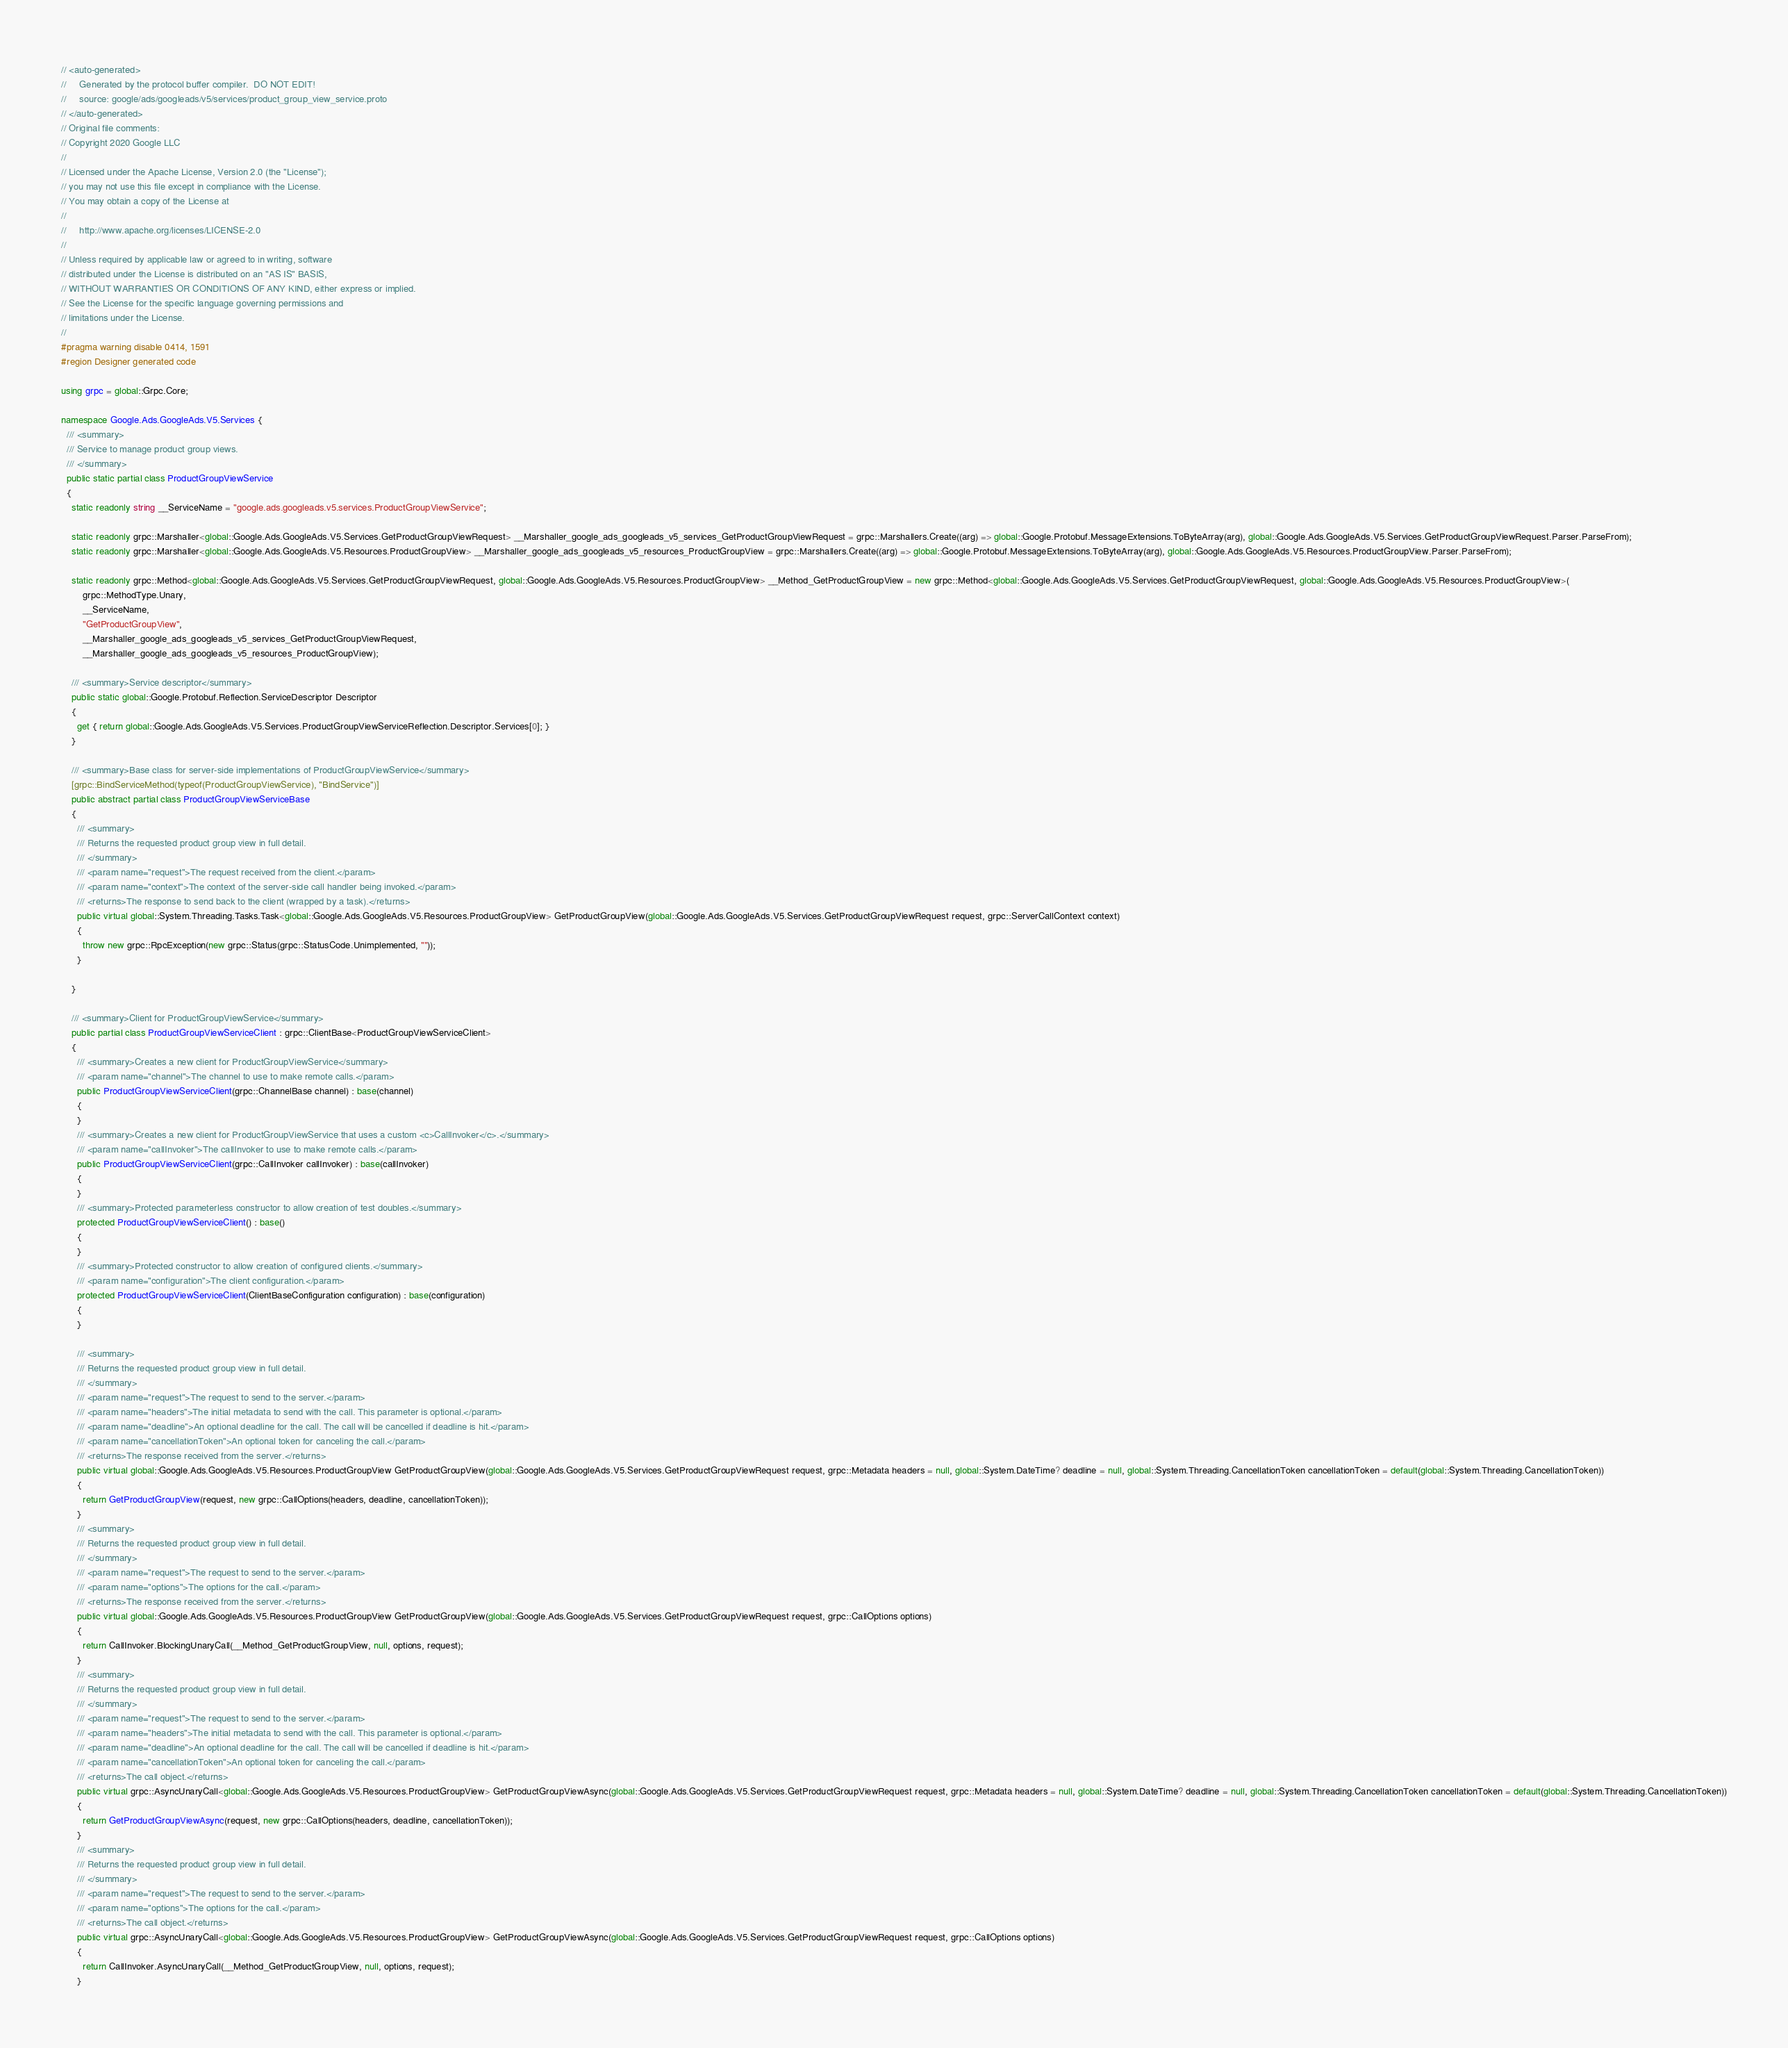<code> <loc_0><loc_0><loc_500><loc_500><_C#_>// <auto-generated>
//     Generated by the protocol buffer compiler.  DO NOT EDIT!
//     source: google/ads/googleads/v5/services/product_group_view_service.proto
// </auto-generated>
// Original file comments:
// Copyright 2020 Google LLC
//
// Licensed under the Apache License, Version 2.0 (the "License");
// you may not use this file except in compliance with the License.
// You may obtain a copy of the License at
//
//     http://www.apache.org/licenses/LICENSE-2.0
//
// Unless required by applicable law or agreed to in writing, software
// distributed under the License is distributed on an "AS IS" BASIS,
// WITHOUT WARRANTIES OR CONDITIONS OF ANY KIND, either express or implied.
// See the License for the specific language governing permissions and
// limitations under the License.
//
#pragma warning disable 0414, 1591
#region Designer generated code

using grpc = global::Grpc.Core;

namespace Google.Ads.GoogleAds.V5.Services {
  /// <summary>
  /// Service to manage product group views.
  /// </summary>
  public static partial class ProductGroupViewService
  {
    static readonly string __ServiceName = "google.ads.googleads.v5.services.ProductGroupViewService";

    static readonly grpc::Marshaller<global::Google.Ads.GoogleAds.V5.Services.GetProductGroupViewRequest> __Marshaller_google_ads_googleads_v5_services_GetProductGroupViewRequest = grpc::Marshallers.Create((arg) => global::Google.Protobuf.MessageExtensions.ToByteArray(arg), global::Google.Ads.GoogleAds.V5.Services.GetProductGroupViewRequest.Parser.ParseFrom);
    static readonly grpc::Marshaller<global::Google.Ads.GoogleAds.V5.Resources.ProductGroupView> __Marshaller_google_ads_googleads_v5_resources_ProductGroupView = grpc::Marshallers.Create((arg) => global::Google.Protobuf.MessageExtensions.ToByteArray(arg), global::Google.Ads.GoogleAds.V5.Resources.ProductGroupView.Parser.ParseFrom);

    static readonly grpc::Method<global::Google.Ads.GoogleAds.V5.Services.GetProductGroupViewRequest, global::Google.Ads.GoogleAds.V5.Resources.ProductGroupView> __Method_GetProductGroupView = new grpc::Method<global::Google.Ads.GoogleAds.V5.Services.GetProductGroupViewRequest, global::Google.Ads.GoogleAds.V5.Resources.ProductGroupView>(
        grpc::MethodType.Unary,
        __ServiceName,
        "GetProductGroupView",
        __Marshaller_google_ads_googleads_v5_services_GetProductGroupViewRequest,
        __Marshaller_google_ads_googleads_v5_resources_ProductGroupView);

    /// <summary>Service descriptor</summary>
    public static global::Google.Protobuf.Reflection.ServiceDescriptor Descriptor
    {
      get { return global::Google.Ads.GoogleAds.V5.Services.ProductGroupViewServiceReflection.Descriptor.Services[0]; }
    }

    /// <summary>Base class for server-side implementations of ProductGroupViewService</summary>
    [grpc::BindServiceMethod(typeof(ProductGroupViewService), "BindService")]
    public abstract partial class ProductGroupViewServiceBase
    {
      /// <summary>
      /// Returns the requested product group view in full detail.
      /// </summary>
      /// <param name="request">The request received from the client.</param>
      /// <param name="context">The context of the server-side call handler being invoked.</param>
      /// <returns>The response to send back to the client (wrapped by a task).</returns>
      public virtual global::System.Threading.Tasks.Task<global::Google.Ads.GoogleAds.V5.Resources.ProductGroupView> GetProductGroupView(global::Google.Ads.GoogleAds.V5.Services.GetProductGroupViewRequest request, grpc::ServerCallContext context)
      {
        throw new grpc::RpcException(new grpc::Status(grpc::StatusCode.Unimplemented, ""));
      }

    }

    /// <summary>Client for ProductGroupViewService</summary>
    public partial class ProductGroupViewServiceClient : grpc::ClientBase<ProductGroupViewServiceClient>
    {
      /// <summary>Creates a new client for ProductGroupViewService</summary>
      /// <param name="channel">The channel to use to make remote calls.</param>
      public ProductGroupViewServiceClient(grpc::ChannelBase channel) : base(channel)
      {
      }
      /// <summary>Creates a new client for ProductGroupViewService that uses a custom <c>CallInvoker</c>.</summary>
      /// <param name="callInvoker">The callInvoker to use to make remote calls.</param>
      public ProductGroupViewServiceClient(grpc::CallInvoker callInvoker) : base(callInvoker)
      {
      }
      /// <summary>Protected parameterless constructor to allow creation of test doubles.</summary>
      protected ProductGroupViewServiceClient() : base()
      {
      }
      /// <summary>Protected constructor to allow creation of configured clients.</summary>
      /// <param name="configuration">The client configuration.</param>
      protected ProductGroupViewServiceClient(ClientBaseConfiguration configuration) : base(configuration)
      {
      }

      /// <summary>
      /// Returns the requested product group view in full detail.
      /// </summary>
      /// <param name="request">The request to send to the server.</param>
      /// <param name="headers">The initial metadata to send with the call. This parameter is optional.</param>
      /// <param name="deadline">An optional deadline for the call. The call will be cancelled if deadline is hit.</param>
      /// <param name="cancellationToken">An optional token for canceling the call.</param>
      /// <returns>The response received from the server.</returns>
      public virtual global::Google.Ads.GoogleAds.V5.Resources.ProductGroupView GetProductGroupView(global::Google.Ads.GoogleAds.V5.Services.GetProductGroupViewRequest request, grpc::Metadata headers = null, global::System.DateTime? deadline = null, global::System.Threading.CancellationToken cancellationToken = default(global::System.Threading.CancellationToken))
      {
        return GetProductGroupView(request, new grpc::CallOptions(headers, deadline, cancellationToken));
      }
      /// <summary>
      /// Returns the requested product group view in full detail.
      /// </summary>
      /// <param name="request">The request to send to the server.</param>
      /// <param name="options">The options for the call.</param>
      /// <returns>The response received from the server.</returns>
      public virtual global::Google.Ads.GoogleAds.V5.Resources.ProductGroupView GetProductGroupView(global::Google.Ads.GoogleAds.V5.Services.GetProductGroupViewRequest request, grpc::CallOptions options)
      {
        return CallInvoker.BlockingUnaryCall(__Method_GetProductGroupView, null, options, request);
      }
      /// <summary>
      /// Returns the requested product group view in full detail.
      /// </summary>
      /// <param name="request">The request to send to the server.</param>
      /// <param name="headers">The initial metadata to send with the call. This parameter is optional.</param>
      /// <param name="deadline">An optional deadline for the call. The call will be cancelled if deadline is hit.</param>
      /// <param name="cancellationToken">An optional token for canceling the call.</param>
      /// <returns>The call object.</returns>
      public virtual grpc::AsyncUnaryCall<global::Google.Ads.GoogleAds.V5.Resources.ProductGroupView> GetProductGroupViewAsync(global::Google.Ads.GoogleAds.V5.Services.GetProductGroupViewRequest request, grpc::Metadata headers = null, global::System.DateTime? deadline = null, global::System.Threading.CancellationToken cancellationToken = default(global::System.Threading.CancellationToken))
      {
        return GetProductGroupViewAsync(request, new grpc::CallOptions(headers, deadline, cancellationToken));
      }
      /// <summary>
      /// Returns the requested product group view in full detail.
      /// </summary>
      /// <param name="request">The request to send to the server.</param>
      /// <param name="options">The options for the call.</param>
      /// <returns>The call object.</returns>
      public virtual grpc::AsyncUnaryCall<global::Google.Ads.GoogleAds.V5.Resources.ProductGroupView> GetProductGroupViewAsync(global::Google.Ads.GoogleAds.V5.Services.GetProductGroupViewRequest request, grpc::CallOptions options)
      {
        return CallInvoker.AsyncUnaryCall(__Method_GetProductGroupView, null, options, request);
      }</code> 